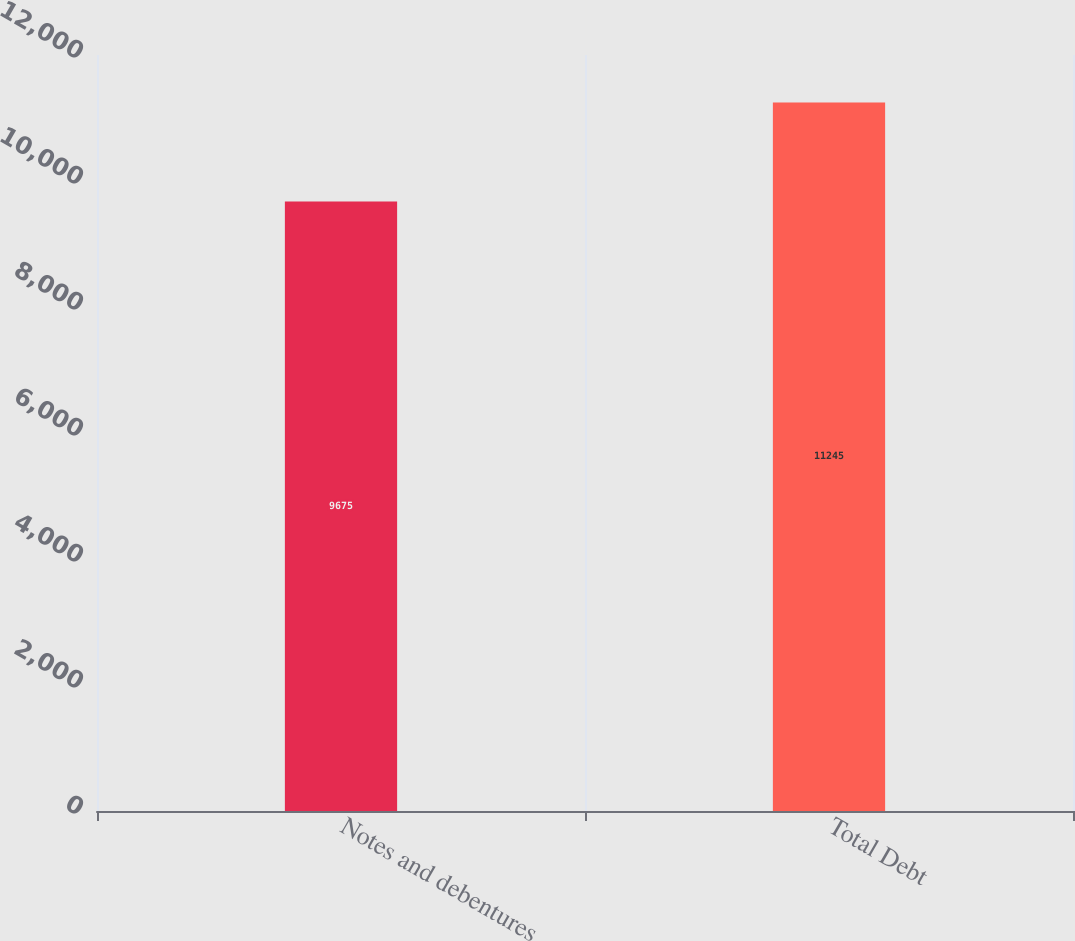<chart> <loc_0><loc_0><loc_500><loc_500><bar_chart><fcel>Notes and debentures<fcel>Total Debt<nl><fcel>9675<fcel>11245<nl></chart> 